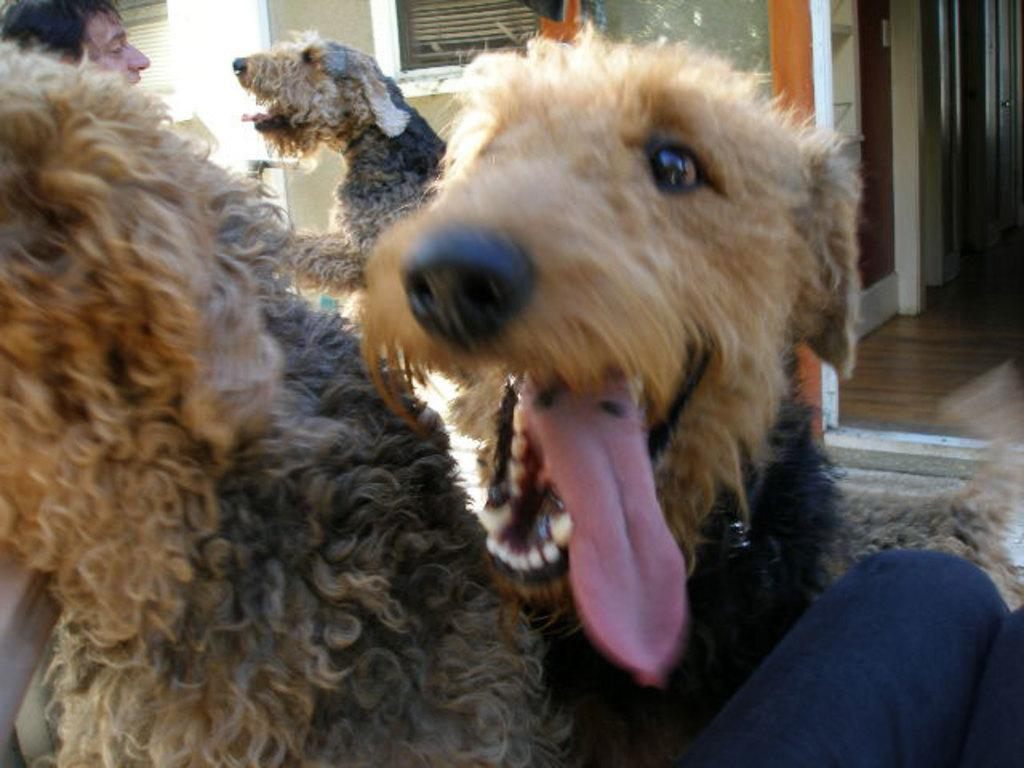What type of animals can be seen in the image? There are dogs in the image. What color are the dogs? The dogs are in brown color. Who is present on the left side of the image? There is a man on the left side of the image. What can be seen in the background of the image? There is a building in the background of the image. What features does the building have? The building has windows and doors. What type of attraction is the man operating in the image? There is no attraction present in the image; it only features dogs, a man, and a building. What rule is being enforced by the rod in the image? There is no rod present in the image, and therefore no rule enforcement can be observed. 